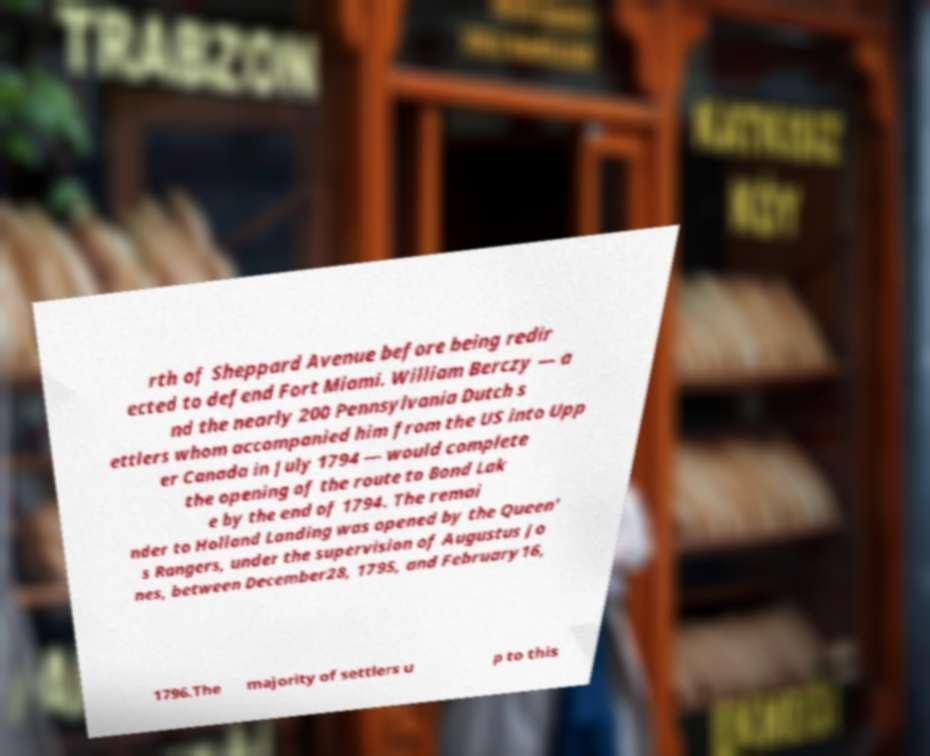Could you assist in decoding the text presented in this image and type it out clearly? rth of Sheppard Avenue before being redir ected to defend Fort Miami. William Berczy — a nd the nearly 200 Pennsylvania Dutch s ettlers whom accompanied him from the US into Upp er Canada in July 1794 — would complete the opening of the route to Bond Lak e by the end of 1794. The remai nder to Holland Landing was opened by the Queen' s Rangers, under the supervision of Augustus Jo nes, between December28, 1795, and February16, 1796.The majority of settlers u p to this 